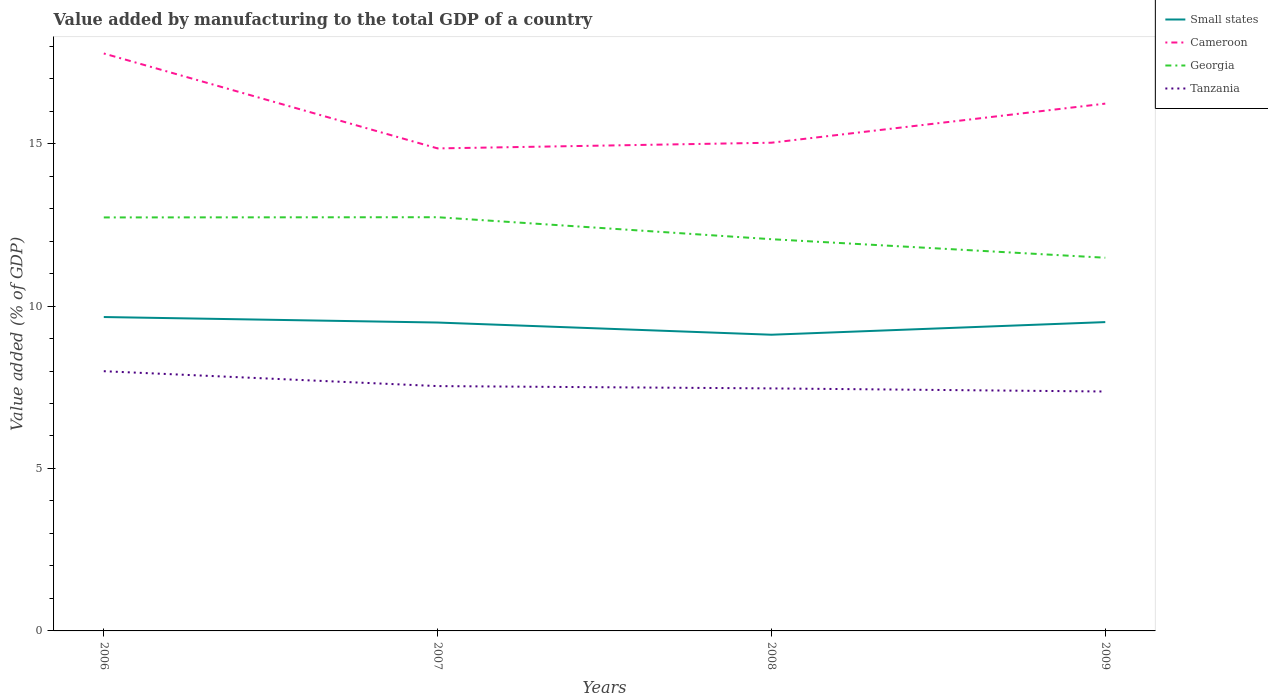Across all years, what is the maximum value added by manufacturing to the total GDP in Small states?
Provide a succinct answer. 9.12. What is the total value added by manufacturing to the total GDP in Tanzania in the graph?
Offer a terse response. 0.46. What is the difference between the highest and the second highest value added by manufacturing to the total GDP in Georgia?
Ensure brevity in your answer.  1.25. Is the value added by manufacturing to the total GDP in Georgia strictly greater than the value added by manufacturing to the total GDP in Cameroon over the years?
Make the answer very short. Yes. How many lines are there?
Offer a very short reply. 4. What is the difference between two consecutive major ticks on the Y-axis?
Provide a succinct answer. 5. Are the values on the major ticks of Y-axis written in scientific E-notation?
Keep it short and to the point. No. Does the graph contain any zero values?
Offer a very short reply. No. Does the graph contain grids?
Your answer should be very brief. No. Where does the legend appear in the graph?
Keep it short and to the point. Top right. How are the legend labels stacked?
Your response must be concise. Vertical. What is the title of the graph?
Provide a short and direct response. Value added by manufacturing to the total GDP of a country. Does "Bhutan" appear as one of the legend labels in the graph?
Ensure brevity in your answer.  No. What is the label or title of the X-axis?
Give a very brief answer. Years. What is the label or title of the Y-axis?
Offer a terse response. Value added (% of GDP). What is the Value added (% of GDP) in Small states in 2006?
Provide a short and direct response. 9.66. What is the Value added (% of GDP) of Cameroon in 2006?
Give a very brief answer. 17.77. What is the Value added (% of GDP) in Georgia in 2006?
Offer a terse response. 12.73. What is the Value added (% of GDP) in Tanzania in 2006?
Offer a terse response. 7.99. What is the Value added (% of GDP) in Small states in 2007?
Provide a succinct answer. 9.49. What is the Value added (% of GDP) in Cameroon in 2007?
Offer a terse response. 14.85. What is the Value added (% of GDP) in Georgia in 2007?
Your answer should be compact. 12.73. What is the Value added (% of GDP) of Tanzania in 2007?
Offer a very short reply. 7.54. What is the Value added (% of GDP) of Small states in 2008?
Provide a succinct answer. 9.12. What is the Value added (% of GDP) in Cameroon in 2008?
Your answer should be very brief. 15.03. What is the Value added (% of GDP) in Georgia in 2008?
Your response must be concise. 12.06. What is the Value added (% of GDP) in Tanzania in 2008?
Offer a very short reply. 7.46. What is the Value added (% of GDP) of Small states in 2009?
Provide a succinct answer. 9.51. What is the Value added (% of GDP) of Cameroon in 2009?
Make the answer very short. 16.23. What is the Value added (% of GDP) of Georgia in 2009?
Make the answer very short. 11.49. What is the Value added (% of GDP) of Tanzania in 2009?
Offer a very short reply. 7.37. Across all years, what is the maximum Value added (% of GDP) of Small states?
Give a very brief answer. 9.66. Across all years, what is the maximum Value added (% of GDP) of Cameroon?
Your answer should be compact. 17.77. Across all years, what is the maximum Value added (% of GDP) in Georgia?
Offer a very short reply. 12.73. Across all years, what is the maximum Value added (% of GDP) of Tanzania?
Your answer should be very brief. 7.99. Across all years, what is the minimum Value added (% of GDP) in Small states?
Provide a succinct answer. 9.12. Across all years, what is the minimum Value added (% of GDP) in Cameroon?
Give a very brief answer. 14.85. Across all years, what is the minimum Value added (% of GDP) of Georgia?
Give a very brief answer. 11.49. Across all years, what is the minimum Value added (% of GDP) in Tanzania?
Give a very brief answer. 7.37. What is the total Value added (% of GDP) of Small states in the graph?
Offer a terse response. 37.78. What is the total Value added (% of GDP) of Cameroon in the graph?
Your answer should be compact. 63.88. What is the total Value added (% of GDP) of Georgia in the graph?
Offer a terse response. 49. What is the total Value added (% of GDP) in Tanzania in the graph?
Offer a very short reply. 30.36. What is the difference between the Value added (% of GDP) of Small states in 2006 and that in 2007?
Keep it short and to the point. 0.17. What is the difference between the Value added (% of GDP) of Cameroon in 2006 and that in 2007?
Offer a very short reply. 2.92. What is the difference between the Value added (% of GDP) of Georgia in 2006 and that in 2007?
Your answer should be very brief. -0.01. What is the difference between the Value added (% of GDP) of Tanzania in 2006 and that in 2007?
Provide a succinct answer. 0.46. What is the difference between the Value added (% of GDP) of Small states in 2006 and that in 2008?
Your response must be concise. 0.54. What is the difference between the Value added (% of GDP) in Cameroon in 2006 and that in 2008?
Offer a terse response. 2.75. What is the difference between the Value added (% of GDP) of Georgia in 2006 and that in 2008?
Ensure brevity in your answer.  0.67. What is the difference between the Value added (% of GDP) of Tanzania in 2006 and that in 2008?
Give a very brief answer. 0.53. What is the difference between the Value added (% of GDP) of Small states in 2006 and that in 2009?
Your answer should be very brief. 0.16. What is the difference between the Value added (% of GDP) in Cameroon in 2006 and that in 2009?
Your answer should be compact. 1.54. What is the difference between the Value added (% of GDP) of Georgia in 2006 and that in 2009?
Keep it short and to the point. 1.24. What is the difference between the Value added (% of GDP) of Tanzania in 2006 and that in 2009?
Keep it short and to the point. 0.62. What is the difference between the Value added (% of GDP) of Small states in 2007 and that in 2008?
Make the answer very short. 0.38. What is the difference between the Value added (% of GDP) in Cameroon in 2007 and that in 2008?
Provide a succinct answer. -0.18. What is the difference between the Value added (% of GDP) of Georgia in 2007 and that in 2008?
Provide a short and direct response. 0.68. What is the difference between the Value added (% of GDP) of Tanzania in 2007 and that in 2008?
Provide a short and direct response. 0.07. What is the difference between the Value added (% of GDP) in Small states in 2007 and that in 2009?
Provide a succinct answer. -0.01. What is the difference between the Value added (% of GDP) of Cameroon in 2007 and that in 2009?
Ensure brevity in your answer.  -1.38. What is the difference between the Value added (% of GDP) in Georgia in 2007 and that in 2009?
Offer a terse response. 1.25. What is the difference between the Value added (% of GDP) in Tanzania in 2007 and that in 2009?
Make the answer very short. 0.17. What is the difference between the Value added (% of GDP) in Small states in 2008 and that in 2009?
Your answer should be very brief. -0.39. What is the difference between the Value added (% of GDP) of Cameroon in 2008 and that in 2009?
Offer a terse response. -1.2. What is the difference between the Value added (% of GDP) in Georgia in 2008 and that in 2009?
Give a very brief answer. 0.57. What is the difference between the Value added (% of GDP) of Tanzania in 2008 and that in 2009?
Give a very brief answer. 0.1. What is the difference between the Value added (% of GDP) of Small states in 2006 and the Value added (% of GDP) of Cameroon in 2007?
Ensure brevity in your answer.  -5.19. What is the difference between the Value added (% of GDP) in Small states in 2006 and the Value added (% of GDP) in Georgia in 2007?
Give a very brief answer. -3.07. What is the difference between the Value added (% of GDP) in Small states in 2006 and the Value added (% of GDP) in Tanzania in 2007?
Your response must be concise. 2.13. What is the difference between the Value added (% of GDP) of Cameroon in 2006 and the Value added (% of GDP) of Georgia in 2007?
Your answer should be very brief. 5.04. What is the difference between the Value added (% of GDP) in Cameroon in 2006 and the Value added (% of GDP) in Tanzania in 2007?
Offer a very short reply. 10.24. What is the difference between the Value added (% of GDP) of Georgia in 2006 and the Value added (% of GDP) of Tanzania in 2007?
Your answer should be very brief. 5.19. What is the difference between the Value added (% of GDP) of Small states in 2006 and the Value added (% of GDP) of Cameroon in 2008?
Ensure brevity in your answer.  -5.37. What is the difference between the Value added (% of GDP) of Small states in 2006 and the Value added (% of GDP) of Georgia in 2008?
Your response must be concise. -2.4. What is the difference between the Value added (% of GDP) of Small states in 2006 and the Value added (% of GDP) of Tanzania in 2008?
Ensure brevity in your answer.  2.2. What is the difference between the Value added (% of GDP) of Cameroon in 2006 and the Value added (% of GDP) of Georgia in 2008?
Provide a short and direct response. 5.72. What is the difference between the Value added (% of GDP) of Cameroon in 2006 and the Value added (% of GDP) of Tanzania in 2008?
Provide a succinct answer. 10.31. What is the difference between the Value added (% of GDP) of Georgia in 2006 and the Value added (% of GDP) of Tanzania in 2008?
Give a very brief answer. 5.26. What is the difference between the Value added (% of GDP) in Small states in 2006 and the Value added (% of GDP) in Cameroon in 2009?
Offer a terse response. -6.57. What is the difference between the Value added (% of GDP) of Small states in 2006 and the Value added (% of GDP) of Georgia in 2009?
Your answer should be very brief. -1.82. What is the difference between the Value added (% of GDP) in Small states in 2006 and the Value added (% of GDP) in Tanzania in 2009?
Make the answer very short. 2.29. What is the difference between the Value added (% of GDP) in Cameroon in 2006 and the Value added (% of GDP) in Georgia in 2009?
Your answer should be very brief. 6.29. What is the difference between the Value added (% of GDP) of Cameroon in 2006 and the Value added (% of GDP) of Tanzania in 2009?
Provide a short and direct response. 10.4. What is the difference between the Value added (% of GDP) in Georgia in 2006 and the Value added (% of GDP) in Tanzania in 2009?
Keep it short and to the point. 5.36. What is the difference between the Value added (% of GDP) of Small states in 2007 and the Value added (% of GDP) of Cameroon in 2008?
Give a very brief answer. -5.53. What is the difference between the Value added (% of GDP) of Small states in 2007 and the Value added (% of GDP) of Georgia in 2008?
Offer a terse response. -2.56. What is the difference between the Value added (% of GDP) in Small states in 2007 and the Value added (% of GDP) in Tanzania in 2008?
Provide a short and direct response. 2.03. What is the difference between the Value added (% of GDP) in Cameroon in 2007 and the Value added (% of GDP) in Georgia in 2008?
Your answer should be compact. 2.79. What is the difference between the Value added (% of GDP) in Cameroon in 2007 and the Value added (% of GDP) in Tanzania in 2008?
Your answer should be compact. 7.39. What is the difference between the Value added (% of GDP) of Georgia in 2007 and the Value added (% of GDP) of Tanzania in 2008?
Give a very brief answer. 5.27. What is the difference between the Value added (% of GDP) in Small states in 2007 and the Value added (% of GDP) in Cameroon in 2009?
Give a very brief answer. -6.74. What is the difference between the Value added (% of GDP) in Small states in 2007 and the Value added (% of GDP) in Georgia in 2009?
Keep it short and to the point. -1.99. What is the difference between the Value added (% of GDP) of Small states in 2007 and the Value added (% of GDP) of Tanzania in 2009?
Provide a short and direct response. 2.12. What is the difference between the Value added (% of GDP) of Cameroon in 2007 and the Value added (% of GDP) of Georgia in 2009?
Make the answer very short. 3.36. What is the difference between the Value added (% of GDP) in Cameroon in 2007 and the Value added (% of GDP) in Tanzania in 2009?
Your answer should be compact. 7.48. What is the difference between the Value added (% of GDP) in Georgia in 2007 and the Value added (% of GDP) in Tanzania in 2009?
Give a very brief answer. 5.36. What is the difference between the Value added (% of GDP) in Small states in 2008 and the Value added (% of GDP) in Cameroon in 2009?
Your answer should be very brief. -7.11. What is the difference between the Value added (% of GDP) of Small states in 2008 and the Value added (% of GDP) of Georgia in 2009?
Offer a very short reply. -2.37. What is the difference between the Value added (% of GDP) of Small states in 2008 and the Value added (% of GDP) of Tanzania in 2009?
Keep it short and to the point. 1.75. What is the difference between the Value added (% of GDP) of Cameroon in 2008 and the Value added (% of GDP) of Georgia in 2009?
Give a very brief answer. 3.54. What is the difference between the Value added (% of GDP) in Cameroon in 2008 and the Value added (% of GDP) in Tanzania in 2009?
Your answer should be compact. 7.66. What is the difference between the Value added (% of GDP) of Georgia in 2008 and the Value added (% of GDP) of Tanzania in 2009?
Give a very brief answer. 4.69. What is the average Value added (% of GDP) of Small states per year?
Offer a very short reply. 9.44. What is the average Value added (% of GDP) in Cameroon per year?
Keep it short and to the point. 15.97. What is the average Value added (% of GDP) in Georgia per year?
Your answer should be very brief. 12.25. What is the average Value added (% of GDP) in Tanzania per year?
Give a very brief answer. 7.59. In the year 2006, what is the difference between the Value added (% of GDP) of Small states and Value added (% of GDP) of Cameroon?
Ensure brevity in your answer.  -8.11. In the year 2006, what is the difference between the Value added (% of GDP) of Small states and Value added (% of GDP) of Georgia?
Your response must be concise. -3.07. In the year 2006, what is the difference between the Value added (% of GDP) of Small states and Value added (% of GDP) of Tanzania?
Your answer should be compact. 1.67. In the year 2006, what is the difference between the Value added (% of GDP) of Cameroon and Value added (% of GDP) of Georgia?
Your response must be concise. 5.05. In the year 2006, what is the difference between the Value added (% of GDP) of Cameroon and Value added (% of GDP) of Tanzania?
Your answer should be compact. 9.78. In the year 2006, what is the difference between the Value added (% of GDP) of Georgia and Value added (% of GDP) of Tanzania?
Keep it short and to the point. 4.73. In the year 2007, what is the difference between the Value added (% of GDP) of Small states and Value added (% of GDP) of Cameroon?
Offer a very short reply. -5.36. In the year 2007, what is the difference between the Value added (% of GDP) in Small states and Value added (% of GDP) in Georgia?
Your answer should be very brief. -3.24. In the year 2007, what is the difference between the Value added (% of GDP) of Small states and Value added (% of GDP) of Tanzania?
Provide a short and direct response. 1.96. In the year 2007, what is the difference between the Value added (% of GDP) of Cameroon and Value added (% of GDP) of Georgia?
Your response must be concise. 2.12. In the year 2007, what is the difference between the Value added (% of GDP) in Cameroon and Value added (% of GDP) in Tanzania?
Provide a succinct answer. 7.32. In the year 2007, what is the difference between the Value added (% of GDP) in Georgia and Value added (% of GDP) in Tanzania?
Your answer should be compact. 5.2. In the year 2008, what is the difference between the Value added (% of GDP) of Small states and Value added (% of GDP) of Cameroon?
Make the answer very short. -5.91. In the year 2008, what is the difference between the Value added (% of GDP) of Small states and Value added (% of GDP) of Georgia?
Ensure brevity in your answer.  -2.94. In the year 2008, what is the difference between the Value added (% of GDP) in Small states and Value added (% of GDP) in Tanzania?
Provide a succinct answer. 1.65. In the year 2008, what is the difference between the Value added (% of GDP) in Cameroon and Value added (% of GDP) in Georgia?
Make the answer very short. 2.97. In the year 2008, what is the difference between the Value added (% of GDP) in Cameroon and Value added (% of GDP) in Tanzania?
Offer a terse response. 7.56. In the year 2008, what is the difference between the Value added (% of GDP) of Georgia and Value added (% of GDP) of Tanzania?
Provide a succinct answer. 4.59. In the year 2009, what is the difference between the Value added (% of GDP) in Small states and Value added (% of GDP) in Cameroon?
Keep it short and to the point. -6.72. In the year 2009, what is the difference between the Value added (% of GDP) of Small states and Value added (% of GDP) of Georgia?
Offer a terse response. -1.98. In the year 2009, what is the difference between the Value added (% of GDP) in Small states and Value added (% of GDP) in Tanzania?
Your answer should be very brief. 2.14. In the year 2009, what is the difference between the Value added (% of GDP) in Cameroon and Value added (% of GDP) in Georgia?
Your answer should be compact. 4.74. In the year 2009, what is the difference between the Value added (% of GDP) of Cameroon and Value added (% of GDP) of Tanzania?
Your answer should be very brief. 8.86. In the year 2009, what is the difference between the Value added (% of GDP) of Georgia and Value added (% of GDP) of Tanzania?
Ensure brevity in your answer.  4.12. What is the ratio of the Value added (% of GDP) of Small states in 2006 to that in 2007?
Keep it short and to the point. 1.02. What is the ratio of the Value added (% of GDP) of Cameroon in 2006 to that in 2007?
Ensure brevity in your answer.  1.2. What is the ratio of the Value added (% of GDP) of Tanzania in 2006 to that in 2007?
Provide a succinct answer. 1.06. What is the ratio of the Value added (% of GDP) in Small states in 2006 to that in 2008?
Your answer should be very brief. 1.06. What is the ratio of the Value added (% of GDP) in Cameroon in 2006 to that in 2008?
Make the answer very short. 1.18. What is the ratio of the Value added (% of GDP) of Georgia in 2006 to that in 2008?
Keep it short and to the point. 1.06. What is the ratio of the Value added (% of GDP) of Tanzania in 2006 to that in 2008?
Your answer should be compact. 1.07. What is the ratio of the Value added (% of GDP) in Small states in 2006 to that in 2009?
Make the answer very short. 1.02. What is the ratio of the Value added (% of GDP) in Cameroon in 2006 to that in 2009?
Your answer should be very brief. 1.1. What is the ratio of the Value added (% of GDP) of Georgia in 2006 to that in 2009?
Give a very brief answer. 1.11. What is the ratio of the Value added (% of GDP) in Tanzania in 2006 to that in 2009?
Provide a short and direct response. 1.08. What is the ratio of the Value added (% of GDP) of Small states in 2007 to that in 2008?
Provide a succinct answer. 1.04. What is the ratio of the Value added (% of GDP) in Cameroon in 2007 to that in 2008?
Ensure brevity in your answer.  0.99. What is the ratio of the Value added (% of GDP) in Georgia in 2007 to that in 2008?
Ensure brevity in your answer.  1.06. What is the ratio of the Value added (% of GDP) of Tanzania in 2007 to that in 2008?
Ensure brevity in your answer.  1.01. What is the ratio of the Value added (% of GDP) of Cameroon in 2007 to that in 2009?
Ensure brevity in your answer.  0.92. What is the ratio of the Value added (% of GDP) in Georgia in 2007 to that in 2009?
Offer a very short reply. 1.11. What is the ratio of the Value added (% of GDP) of Tanzania in 2007 to that in 2009?
Ensure brevity in your answer.  1.02. What is the ratio of the Value added (% of GDP) in Small states in 2008 to that in 2009?
Your answer should be very brief. 0.96. What is the ratio of the Value added (% of GDP) of Cameroon in 2008 to that in 2009?
Ensure brevity in your answer.  0.93. What is the ratio of the Value added (% of GDP) of Georgia in 2008 to that in 2009?
Ensure brevity in your answer.  1.05. What is the ratio of the Value added (% of GDP) of Tanzania in 2008 to that in 2009?
Provide a short and direct response. 1.01. What is the difference between the highest and the second highest Value added (% of GDP) in Small states?
Your answer should be very brief. 0.16. What is the difference between the highest and the second highest Value added (% of GDP) in Cameroon?
Your response must be concise. 1.54. What is the difference between the highest and the second highest Value added (% of GDP) in Georgia?
Give a very brief answer. 0.01. What is the difference between the highest and the second highest Value added (% of GDP) of Tanzania?
Offer a very short reply. 0.46. What is the difference between the highest and the lowest Value added (% of GDP) of Small states?
Your answer should be compact. 0.54. What is the difference between the highest and the lowest Value added (% of GDP) of Cameroon?
Make the answer very short. 2.92. What is the difference between the highest and the lowest Value added (% of GDP) of Georgia?
Your response must be concise. 1.25. What is the difference between the highest and the lowest Value added (% of GDP) of Tanzania?
Provide a succinct answer. 0.62. 